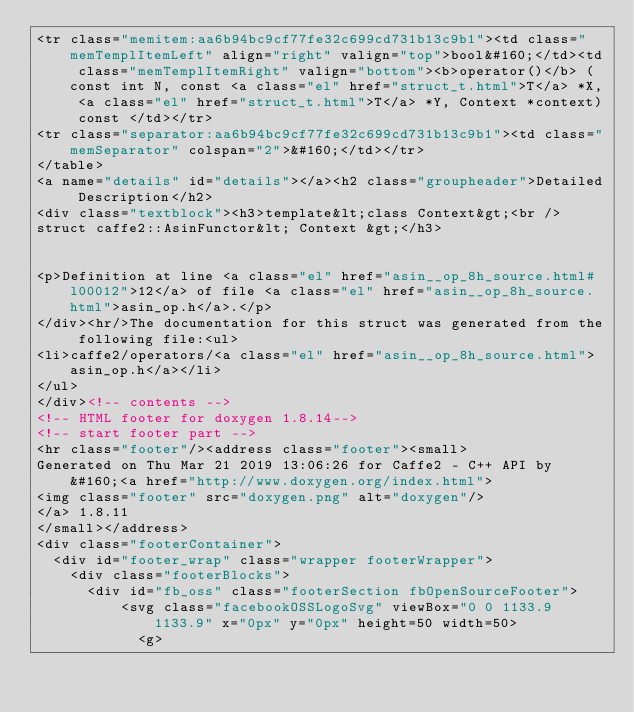<code> <loc_0><loc_0><loc_500><loc_500><_HTML_><tr class="memitem:aa6b94bc9cf77fe32c699cd731b13c9b1"><td class="memTemplItemLeft" align="right" valign="top">bool&#160;</td><td class="memTemplItemRight" valign="bottom"><b>operator()</b> (const int N, const <a class="el" href="struct_t.html">T</a> *X, <a class="el" href="struct_t.html">T</a> *Y, Context *context) const </td></tr>
<tr class="separator:aa6b94bc9cf77fe32c699cd731b13c9b1"><td class="memSeparator" colspan="2">&#160;</td></tr>
</table>
<a name="details" id="details"></a><h2 class="groupheader">Detailed Description</h2>
<div class="textblock"><h3>template&lt;class Context&gt;<br />
struct caffe2::AsinFunctor&lt; Context &gt;</h3>


<p>Definition at line <a class="el" href="asin__op_8h_source.html#l00012">12</a> of file <a class="el" href="asin__op_8h_source.html">asin_op.h</a>.</p>
</div><hr/>The documentation for this struct was generated from the following file:<ul>
<li>caffe2/operators/<a class="el" href="asin__op_8h_source.html">asin_op.h</a></li>
</ul>
</div><!-- contents -->
<!-- HTML footer for doxygen 1.8.14-->
<!-- start footer part -->
<hr class="footer"/><address class="footer"><small>
Generated on Thu Mar 21 2019 13:06:26 for Caffe2 - C++ API by &#160;<a href="http://www.doxygen.org/index.html">
<img class="footer" src="doxygen.png" alt="doxygen"/>
</a> 1.8.11
</small></address>
<div class="footerContainer">
  <div id="footer_wrap" class="wrapper footerWrapper">
    <div class="footerBlocks">
      <div id="fb_oss" class="footerSection fbOpenSourceFooter">
          <svg class="facebookOSSLogoSvg" viewBox="0 0 1133.9 1133.9" x="0px" y="0px" height=50 width=50>
            <g></code> 